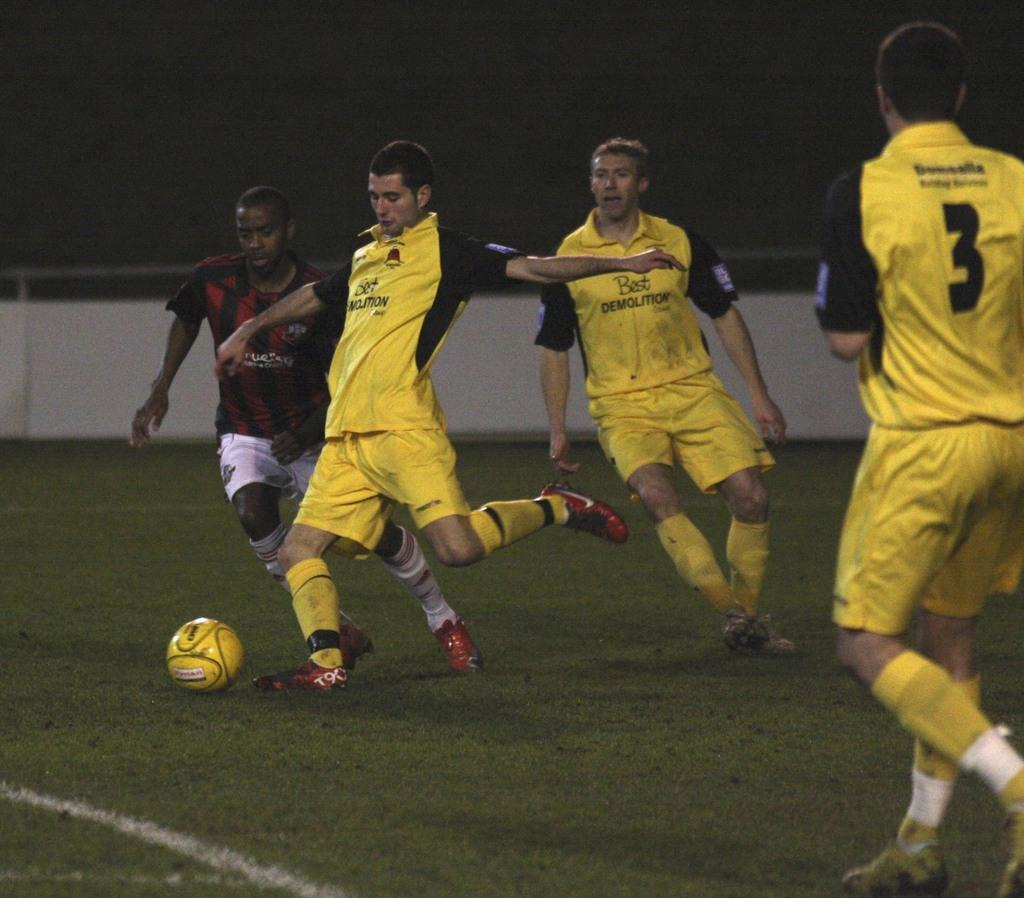Provide a one-sentence caption for the provided image. Man in a number 3 jersey about to receive a pass. 